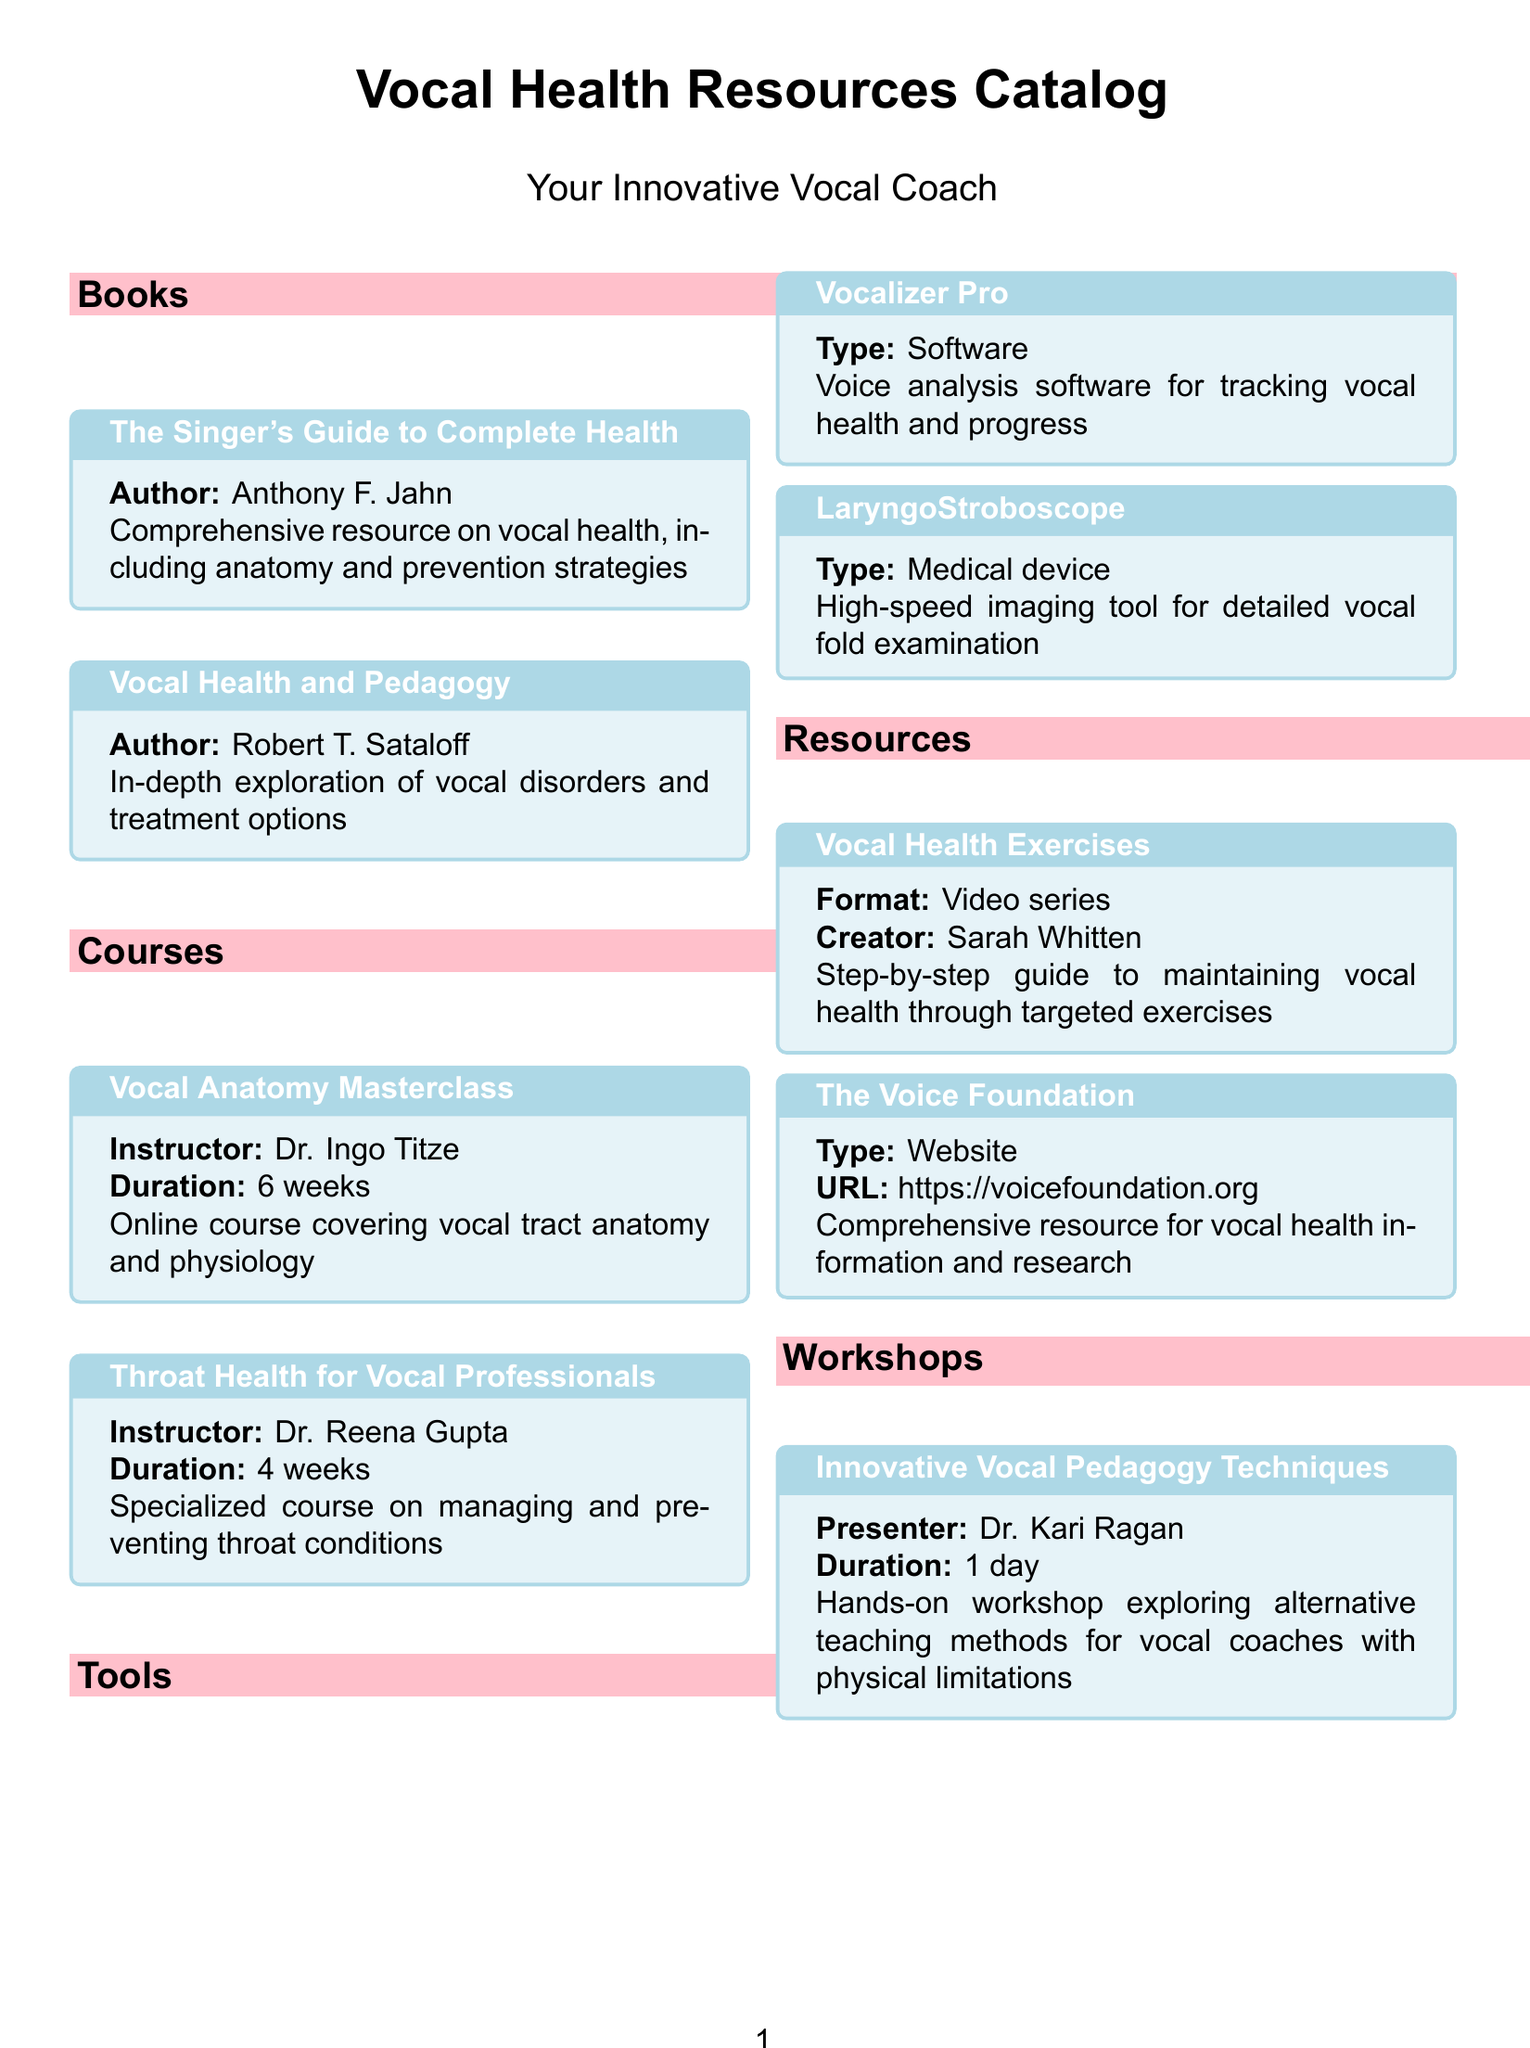What is the title of the first book listed? The title of the first book is the one that appears at the top of the "Books" section, which is "The Singer's Guide to Complete Health."
Answer: The Singer's Guide to Complete Health Who is the instructor of the "Throat Health for Vocal Professionals" course? The instructor's name is provided directly next to the course title in the document, which is "Dr. Reena Gupta."
Answer: Dr. Reena Gupta How long is the "Vocal Anatomy Masterclass" course? The duration of the course is stated right after its title, which is "6 weeks."
Answer: 6 weeks What type of resource is "Vocal Health Exercises"? The type of resource is specified right next to the title in the document, indicating it is a "Video series."
Answer: Video series Who is the presenter of the workshop on innovative vocal pedagogy techniques? The presenter's name is located under the workshop title in the document, which is "Dr. Kari Ragan."
Answer: Dr. Kari Ragan What medical device is listed for vocal fold examination? The medical device is clearly labeled in the "Tools" section of the document, which is "LaryngoStroboscope."
Answer: LaryngoStroboscope What is the URL for The Voice Foundation? The URL is provided directly under the resource title in the catalog, which is "https://voicefoundation.org."
Answer: https://voicefoundation.org What is the focus of the course by Dr. Reena Gupta? The focus is indicated in the title and description of the course, stating it is "managing and preventing throat conditions."
Answer: managing and preventing throat conditions 